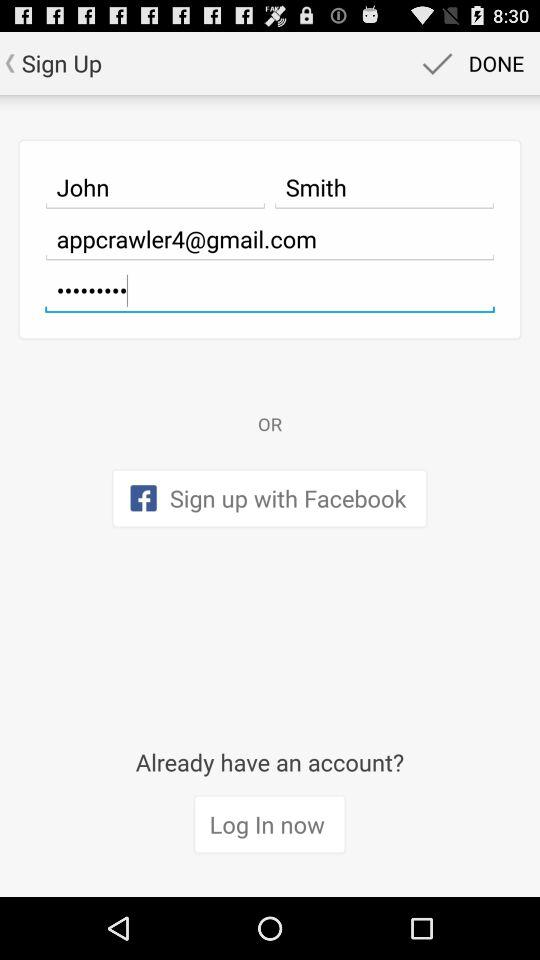What is the name? The name is John Smith. 